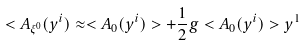<formula> <loc_0><loc_0><loc_500><loc_500>< A _ { \xi ^ { 0 } } ( y ^ { i } ) \approx < A _ { 0 } ( y ^ { i } ) > + \frac { 1 } { 2 } g < A _ { 0 } ( y ^ { i } ) > y ^ { 1 }</formula> 